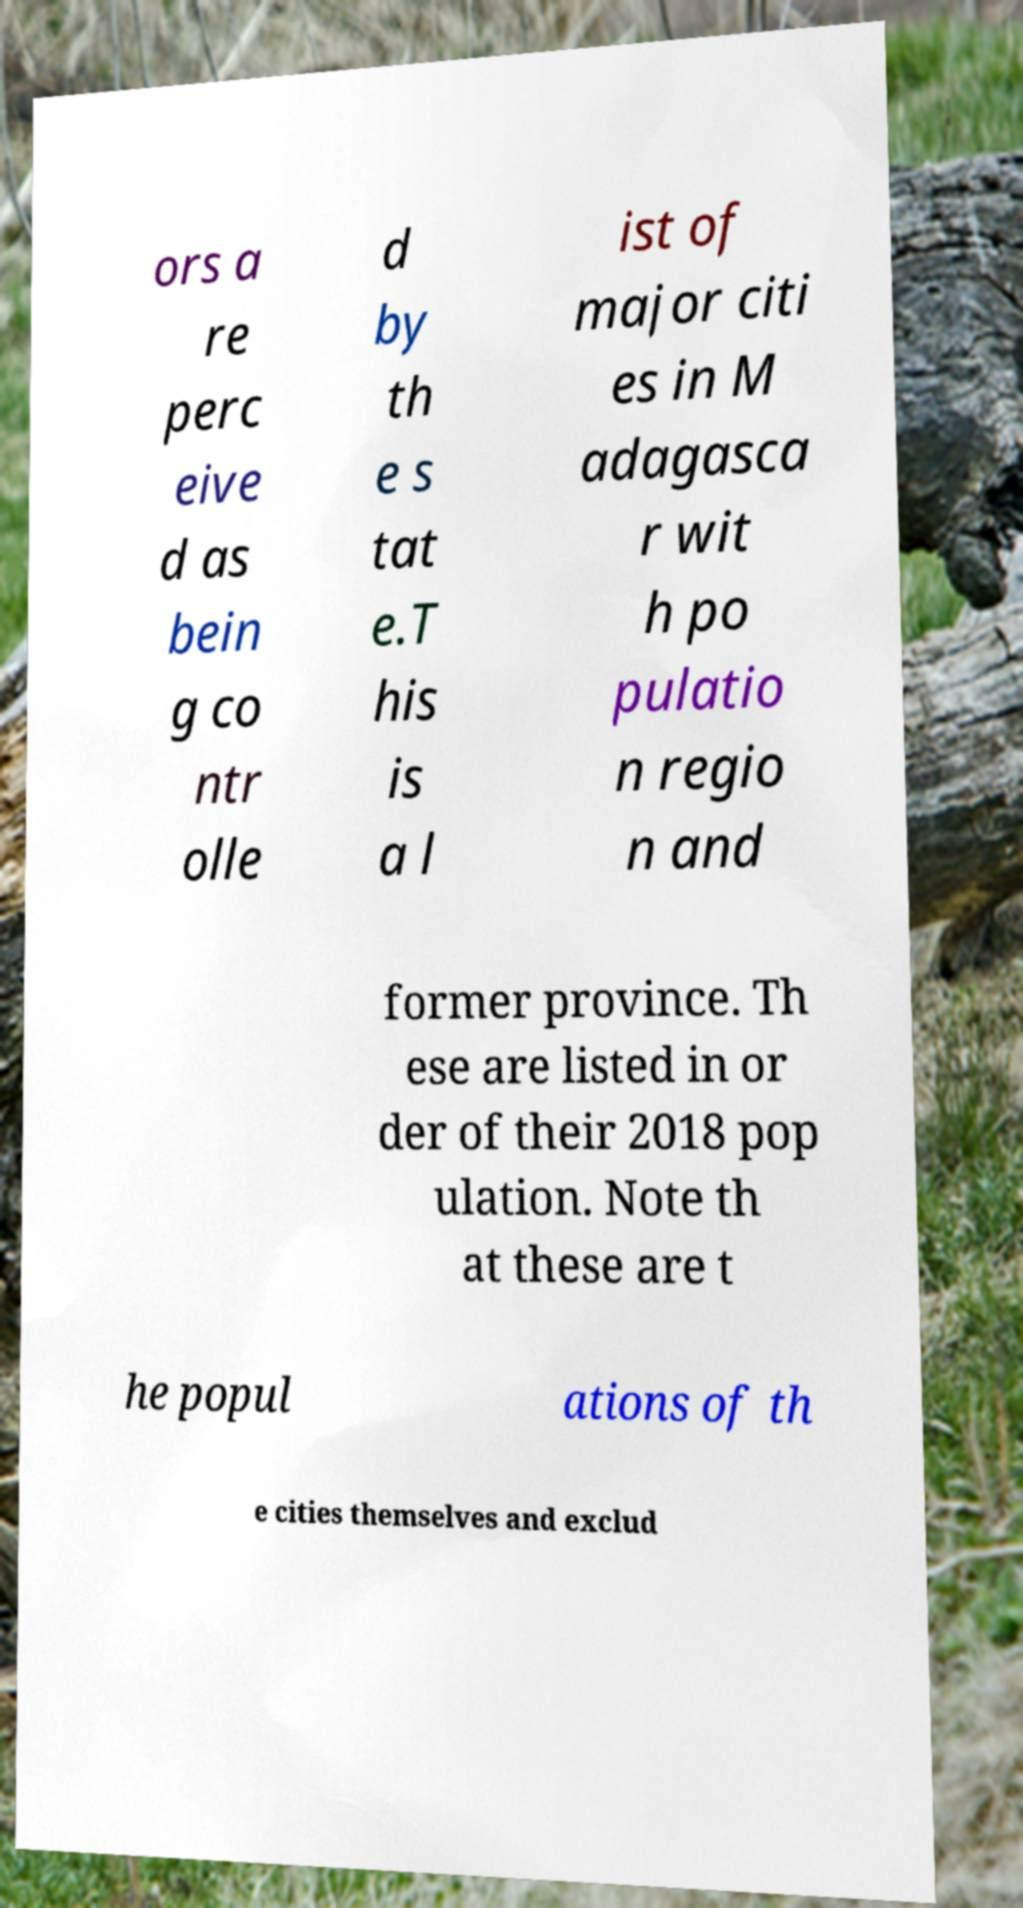For documentation purposes, I need the text within this image transcribed. Could you provide that? ors a re perc eive d as bein g co ntr olle d by th e s tat e.T his is a l ist of major citi es in M adagasca r wit h po pulatio n regio n and former province. Th ese are listed in or der of their 2018 pop ulation. Note th at these are t he popul ations of th e cities themselves and exclud 